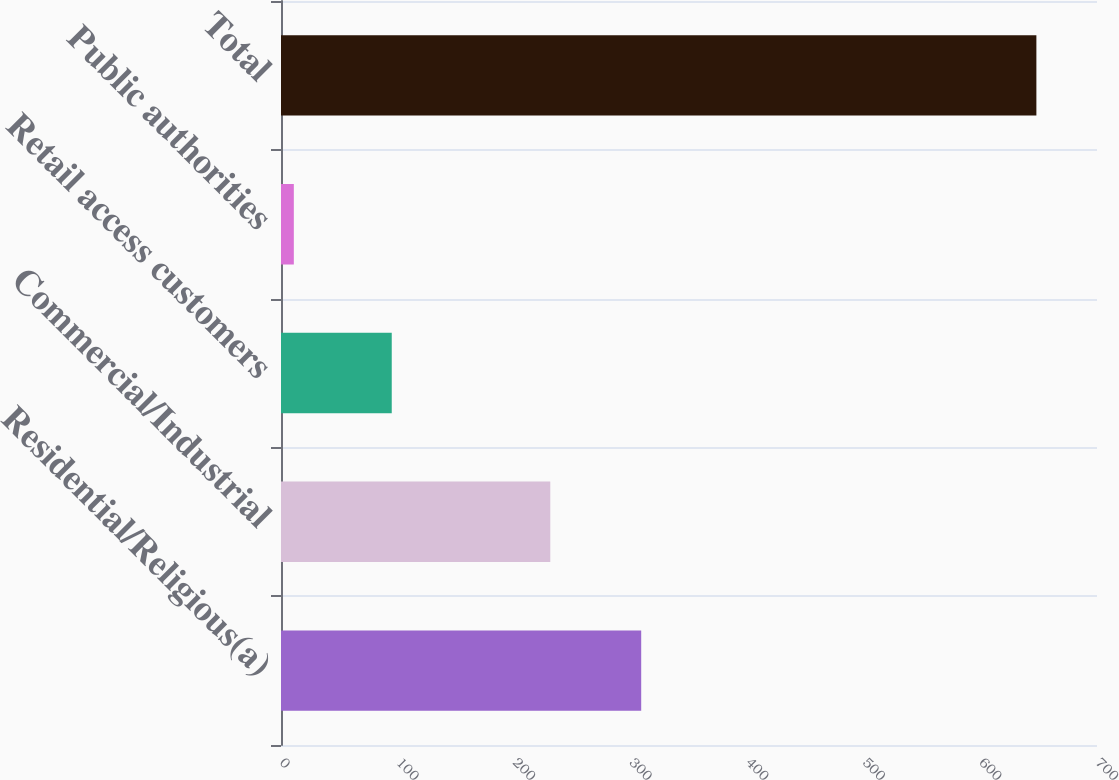Convert chart to OTSL. <chart><loc_0><loc_0><loc_500><loc_500><bar_chart><fcel>Residential/Religious(a)<fcel>Commercial/Industrial<fcel>Retail access customers<fcel>Public authorities<fcel>Total<nl><fcel>309<fcel>231<fcel>95<fcel>11<fcel>648<nl></chart> 